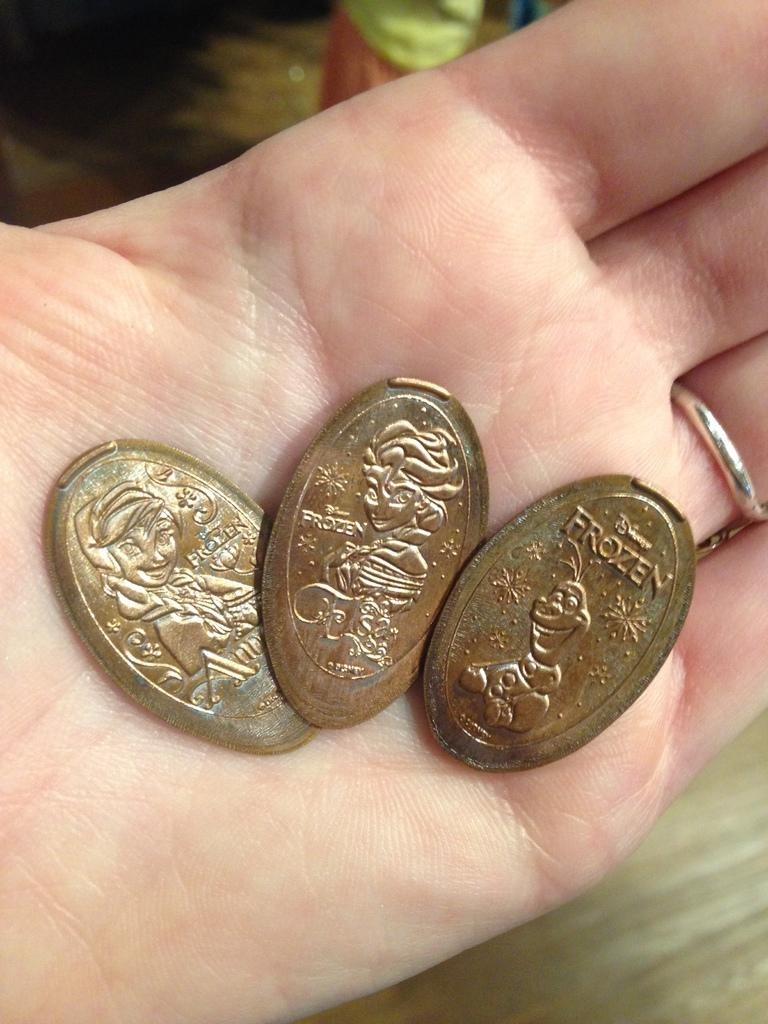<image>
Summarize the visual content of the image. A set of pressed coins all show the word Frozen on them. 